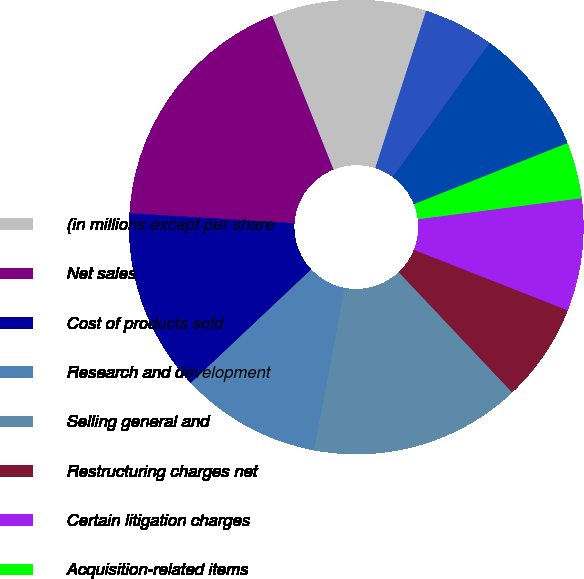Convert chart to OTSL. <chart><loc_0><loc_0><loc_500><loc_500><pie_chart><fcel>(in millions except per share<fcel>Net sales<fcel>Cost of products sold<fcel>Research and development<fcel>Selling general and<fcel>Restructuring charges net<fcel>Certain litigation charges<fcel>Acquisition-related items<fcel>Amortization of intangible<fcel>Other expense net<nl><fcel>11.0%<fcel>18.0%<fcel>13.0%<fcel>10.0%<fcel>15.0%<fcel>7.0%<fcel>8.0%<fcel>4.0%<fcel>9.0%<fcel>5.0%<nl></chart> 